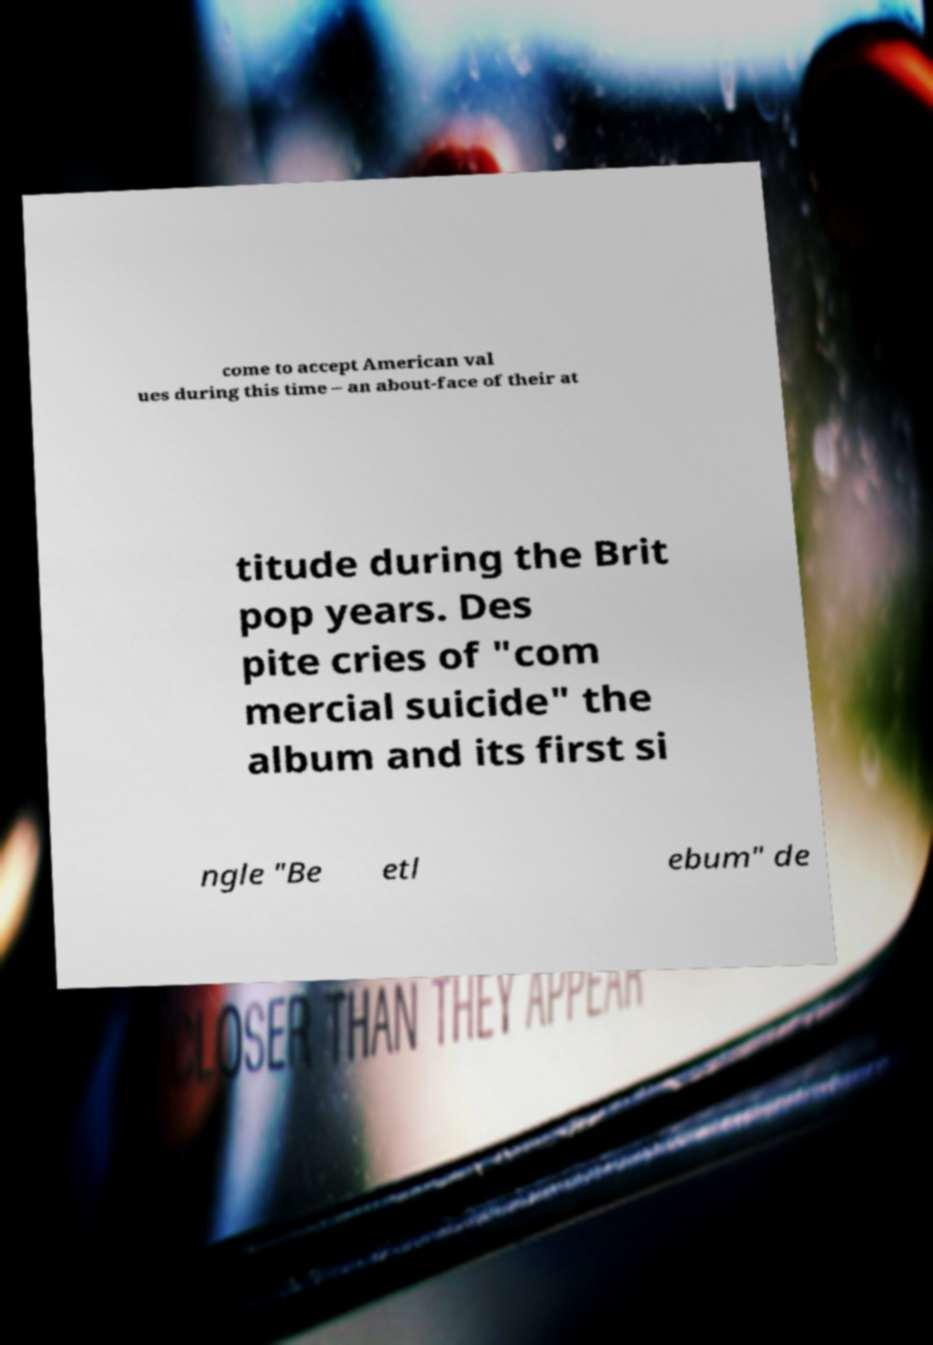Can you read and provide the text displayed in the image?This photo seems to have some interesting text. Can you extract and type it out for me? come to accept American val ues during this time – an about-face of their at titude during the Brit pop years. Des pite cries of "com mercial suicide" the album and its first si ngle "Be etl ebum" de 